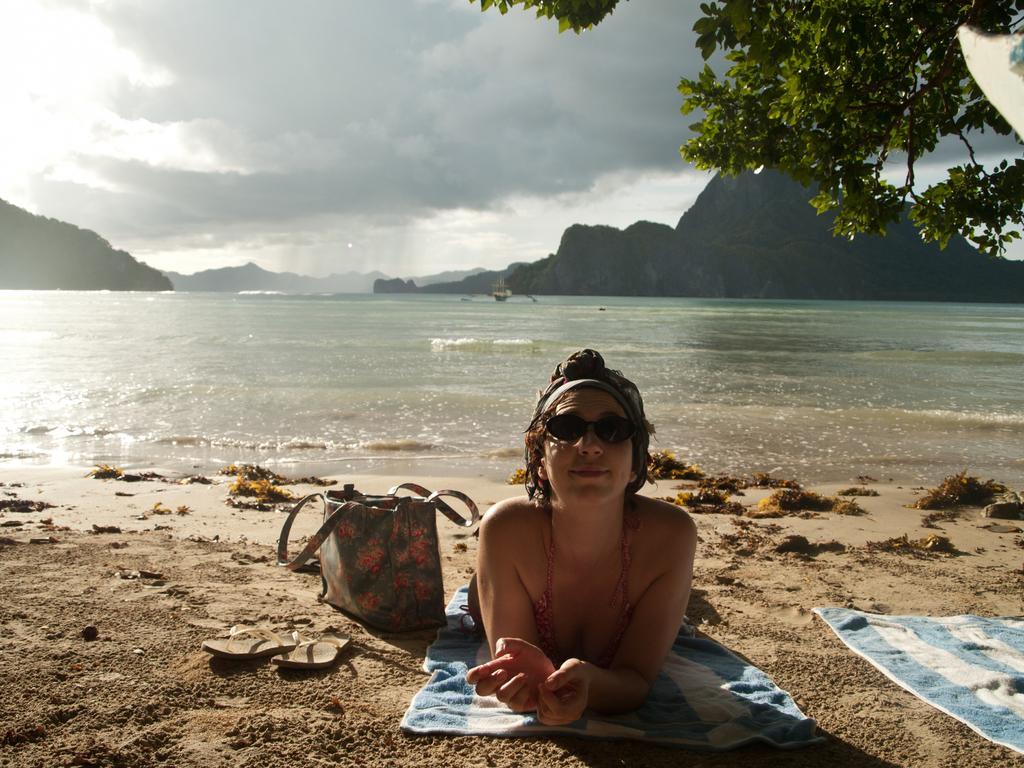Please provide a concise description of this image. Here we can see a woman laying on her towel with handbag and slippers besides her, she is wearing goggles, this probably looks like a beach, the sky is cloudy, here there are mountains the tree is present on the right side 